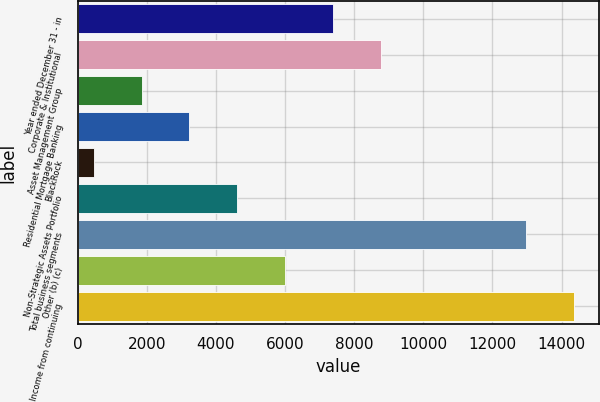Convert chart to OTSL. <chart><loc_0><loc_0><loc_500><loc_500><bar_chart><fcel>Year ended December 31 - in<fcel>Corporate & Institutional<fcel>Asset Management Group<fcel>Residential Mortgage Banking<fcel>BlackRock<fcel>Non-Strategic Assets Portfolio<fcel>Total business segments<fcel>Other (b) (c)<fcel>Income from continuing<nl><fcel>7395<fcel>8781.2<fcel>1850.2<fcel>3236.4<fcel>464<fcel>4622.6<fcel>12970<fcel>6008.8<fcel>14356.2<nl></chart> 